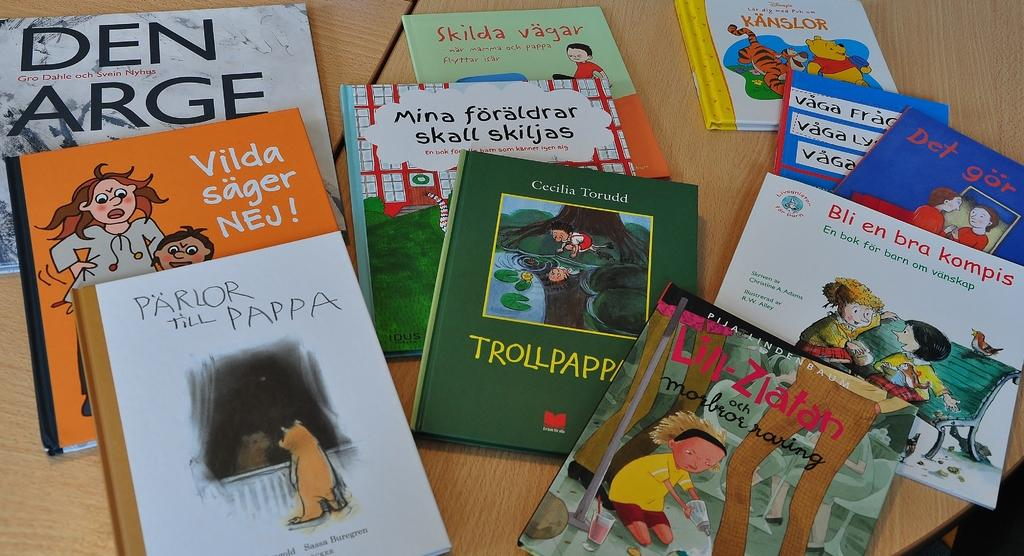Provide a one-sentence caption for the provided image. Several books sitting on a table with titles such as PARLOR THE PAPPA. 